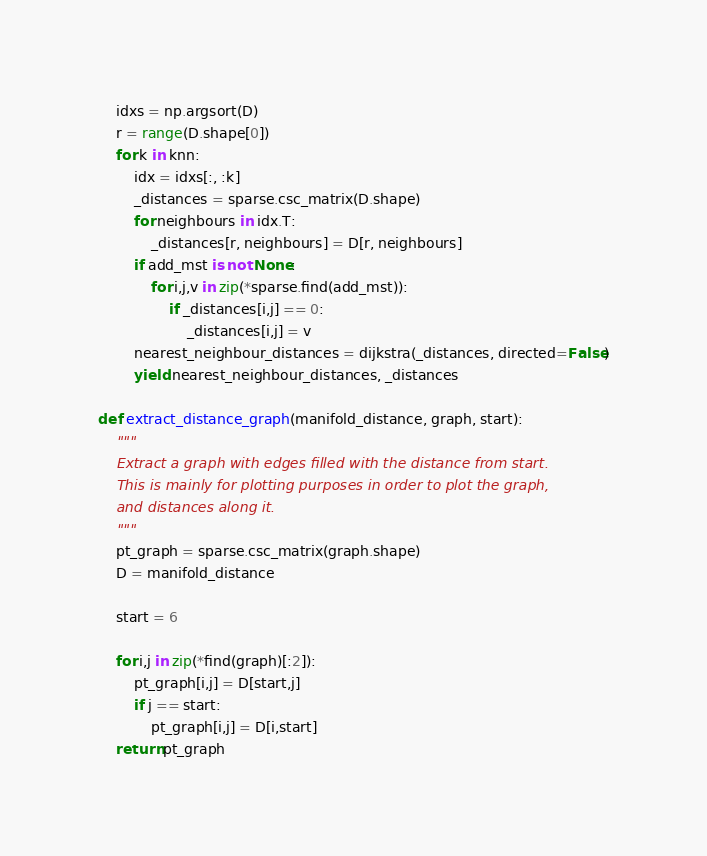Convert code to text. <code><loc_0><loc_0><loc_500><loc_500><_Python_>    idxs = np.argsort(D)
    r = range(D.shape[0])
    for k in knn:
        idx = idxs[:, :k]
        _distances = sparse.csc_matrix(D.shape)
        for neighbours in idx.T:
            _distances[r, neighbours] = D[r, neighbours]
        if add_mst is not None:
            for i,j,v in zip(*sparse.find(add_mst)):
                if _distances[i,j] == 0:
                    _distances[i,j] = v
        nearest_neighbour_distances = dijkstra(_distances, directed=False)
        yield nearest_neighbour_distances, _distances

def extract_distance_graph(manifold_distance, graph, start):
    """
    Extract a graph with edges filled with the distance from start.
    This is mainly for plotting purposes in order to plot the graph,
    and distances along it.
    """
    pt_graph = sparse.csc_matrix(graph.shape)
    D = manifold_distance

    start = 6

    for i,j in zip(*find(graph)[:2]):
        pt_graph[i,j] = D[start,j]
        if j == start:
            pt_graph[i,j] = D[i,start]
    return pt_graph</code> 